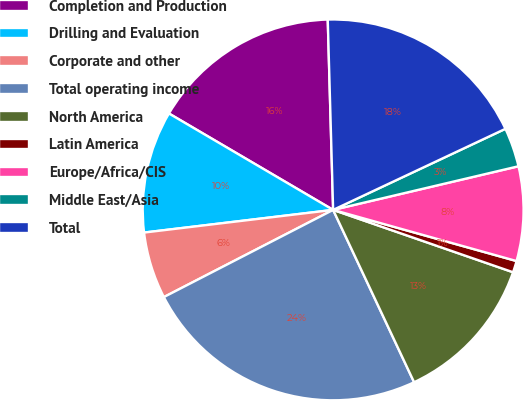Convert chart to OTSL. <chart><loc_0><loc_0><loc_500><loc_500><pie_chart><fcel>Completion and Production<fcel>Drilling and Evaluation<fcel>Corporate and other<fcel>Total operating income<fcel>North America<fcel>Latin America<fcel>Europe/Africa/CIS<fcel>Middle East/Asia<fcel>Total<nl><fcel>16.1%<fcel>10.35%<fcel>5.67%<fcel>24.42%<fcel>12.7%<fcel>0.98%<fcel>8.01%<fcel>3.32%<fcel>18.45%<nl></chart> 